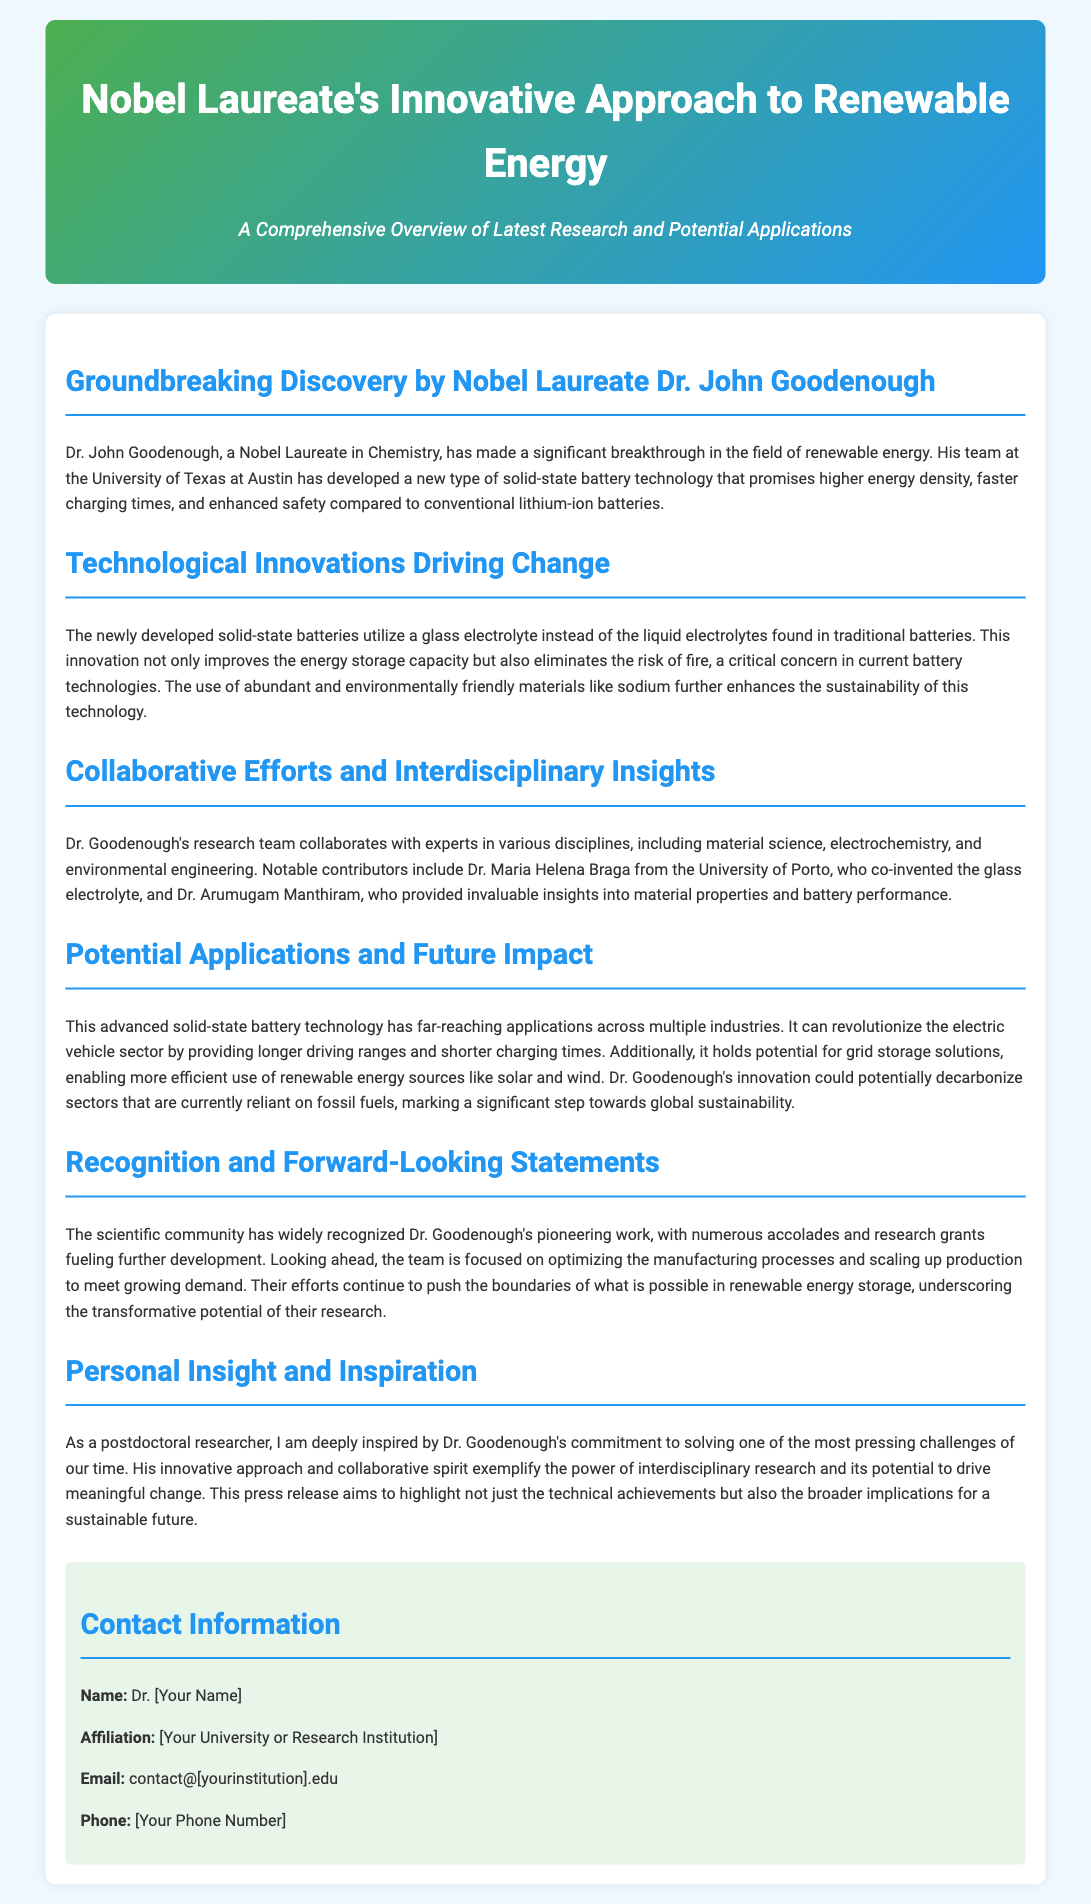What is Dr. John Goodenough's title? Dr. John Goodenough is referred to as a Nobel Laureate in Chemistry, indicating his prestigious recognition.
Answer: Nobel Laureate in Chemistry What type of battery technology has Dr. Goodenough developed? The document specifies that Dr. Goodenough has developed a new type of solid-state battery technology.
Answer: Solid-state battery technology What material is used in the new solid-state batteries? The document mentions that solid-state batteries utilize a glass electrolyte instead of traditional liquid electrolytes.
Answer: Glass electrolyte Who co-invented the glass electrolyte? The document states that Dr. Maria Helena Braga from the University of Porto co-invented the glass electrolyte.
Answer: Dr. Maria Helena Braga What are the potential applications mentioned for the solid-state battery technology? The document lists that this technology can revolutionize the electric vehicle sector and enable more efficient grid storage solutions.
Answer: Electric vehicles and grid storage solutions What is the main environmental benefit of the new battery technology? The document highlights that the use of abundant and environmentally friendly materials like sodium enhances the sustainability of the technology.
Answer: Sustainability What does the future focus of Dr. Goodenough's team entail? The team aims to optimize manufacturing processes and scale up production to meet growing demand.
Answer: Optimize manufacturing processes and scale up production What collaborative areas are mentioned in Dr. Goodenough's research? The document indicates that Dr. Goodenough's research team collaborates with material science, electrochemistry, and environmental engineering experts.
Answer: Material science, electrochemistry, and environmental engineering What is emphasized as a significant aspect of Dr. Goodenough's work? The document emphasizes his commitment to solving pressing challenges, showcasing the power of interdisciplinary research for meaningful change.
Answer: Interdisciplinary research and meaningful change 